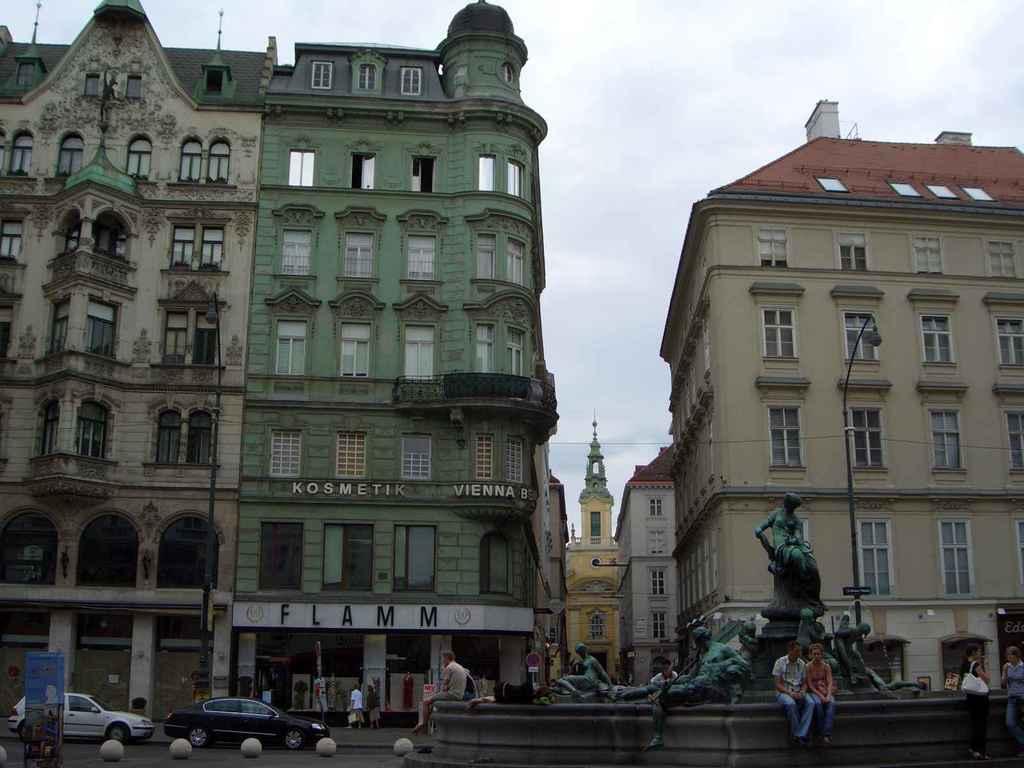What is the name of the place on the first floor?
Offer a terse response. Flamm. 